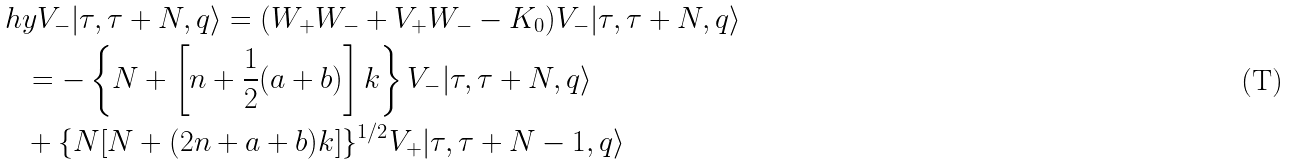Convert formula to latex. <formula><loc_0><loc_0><loc_500><loc_500>& \ h y V _ { - } | \tau , \tau + N , q \rangle = ( W _ { + } W _ { - } + V _ { + } W _ { - } - K _ { 0 } ) V _ { - } | \tau , \tau + N , q \rangle \\ & \quad = - \left \{ N + \left [ n + \frac { 1 } { 2 } ( a + b ) \right ] k \right \} V _ { - } | \tau , \tau + N , q \rangle \\ & \quad + \{ N [ N + ( 2 n + a + b ) k ] \} ^ { 1 / 2 } V _ { + } | \tau , \tau + N - 1 , q \rangle</formula> 